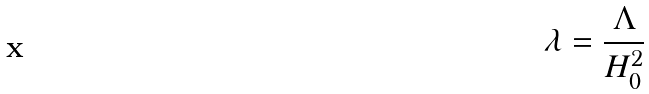Convert formula to latex. <formula><loc_0><loc_0><loc_500><loc_500>\lambda = \frac { \Lambda } { H _ { 0 } ^ { 2 } }</formula> 